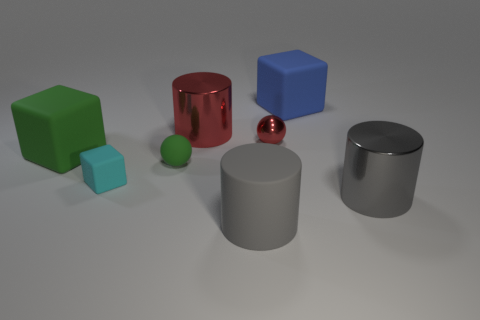What number of gray metallic cylinders are in front of the big cylinder that is behind the ball that is in front of the big green matte object?
Provide a succinct answer. 1. What number of green objects are metallic cylinders or small rubber spheres?
Ensure brevity in your answer.  1. There is a matte cylinder; does it have the same size as the thing behind the large red cylinder?
Make the answer very short. Yes. What material is the other small thing that is the same shape as the small shiny object?
Give a very brief answer. Rubber. How many other things are the same size as the green ball?
Keep it short and to the point. 2. There is a gray object on the left side of the large gray object behind the big gray object that is on the left side of the gray shiny thing; what is its shape?
Give a very brief answer. Cylinder. What shape is the large rubber object that is in front of the tiny metal sphere and behind the gray rubber cylinder?
Keep it short and to the point. Cube. What number of things are either tiny cyan rubber cubes or big red cylinders that are behind the gray matte cylinder?
Provide a succinct answer. 2. Do the tiny red thing and the blue thing have the same material?
Give a very brief answer. No. How many other objects are there of the same shape as the small green thing?
Make the answer very short. 1. 